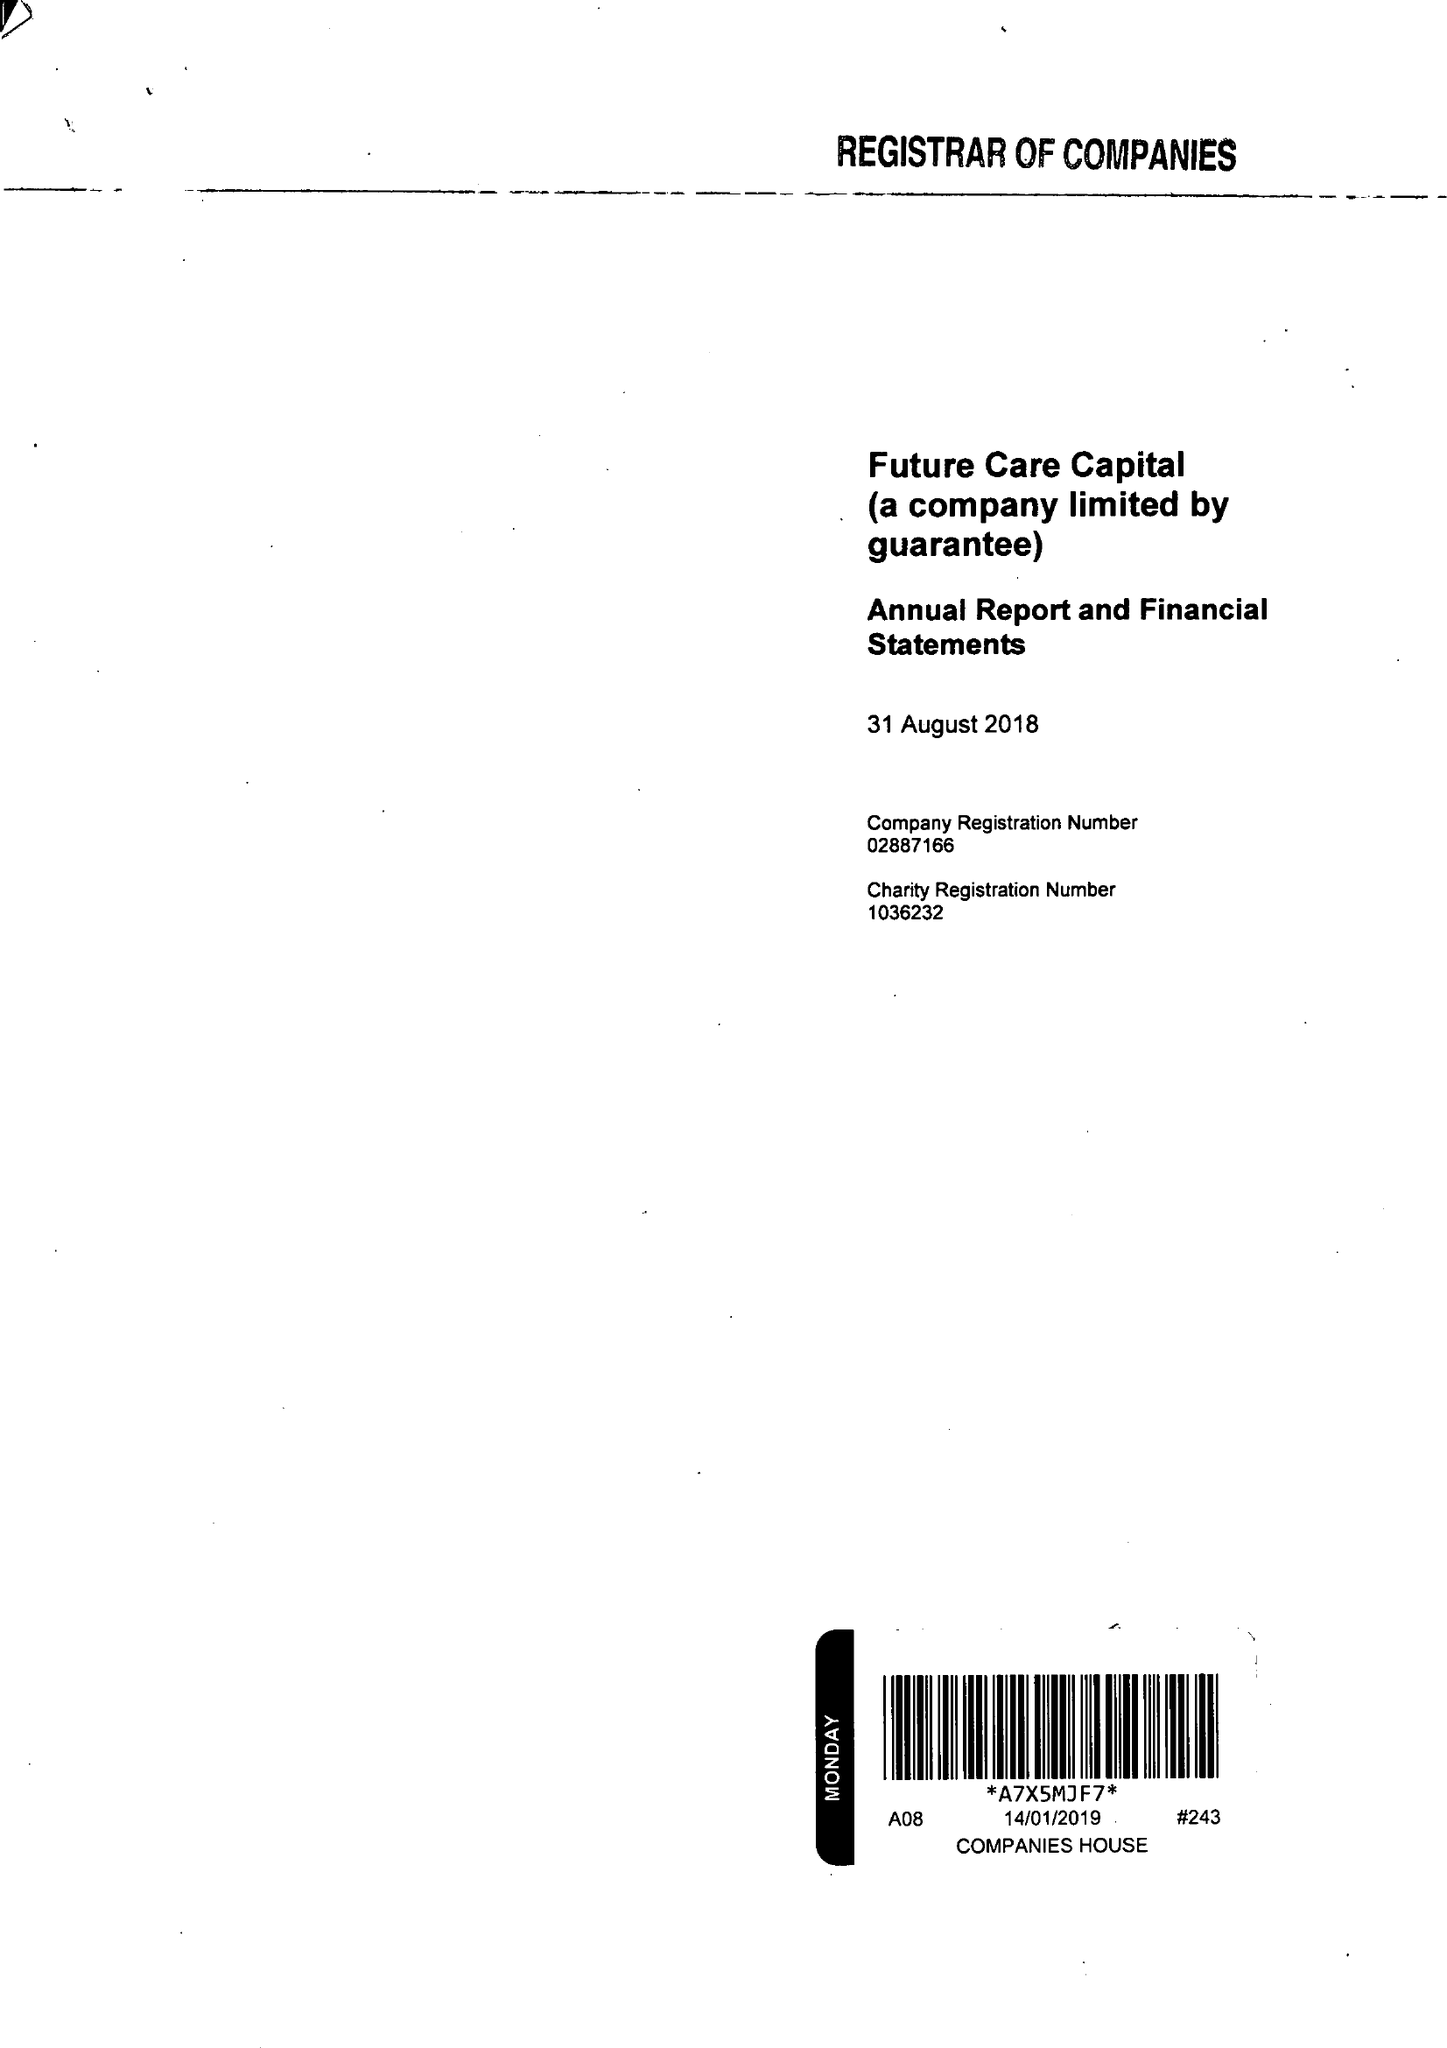What is the value for the address__postcode?
Answer the question using a single word or phrase. SW1V 1HU 